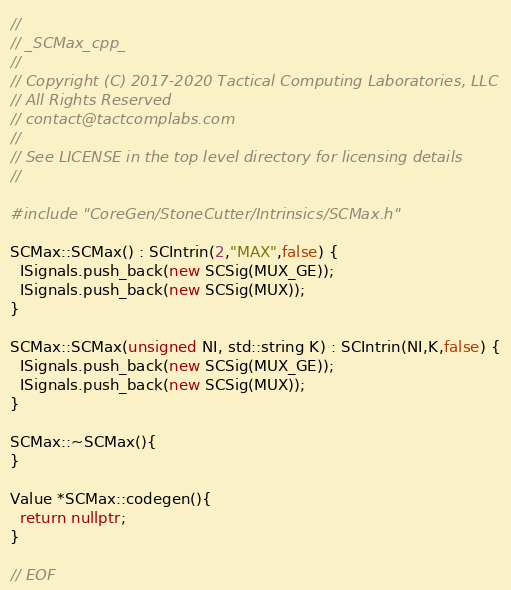<code> <loc_0><loc_0><loc_500><loc_500><_C++_>//
// _SCMax_cpp_
//
// Copyright (C) 2017-2020 Tactical Computing Laboratories, LLC
// All Rights Reserved
// contact@tactcomplabs.com
//
// See LICENSE in the top level directory for licensing details
//

#include "CoreGen/StoneCutter/Intrinsics/SCMax.h"

SCMax::SCMax() : SCIntrin(2,"MAX",false) {
  ISignals.push_back(new SCSig(MUX_GE));
  ISignals.push_back(new SCSig(MUX));
}

SCMax::SCMax(unsigned NI, std::string K) : SCIntrin(NI,K,false) {
  ISignals.push_back(new SCSig(MUX_GE));
  ISignals.push_back(new SCSig(MUX));
}

SCMax::~SCMax(){
}

Value *SCMax::codegen(){
  return nullptr;
}

// EOF
</code> 